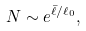<formula> <loc_0><loc_0><loc_500><loc_500>N \sim e ^ { \bar { \ell } / \ell _ { 0 } } ,</formula> 